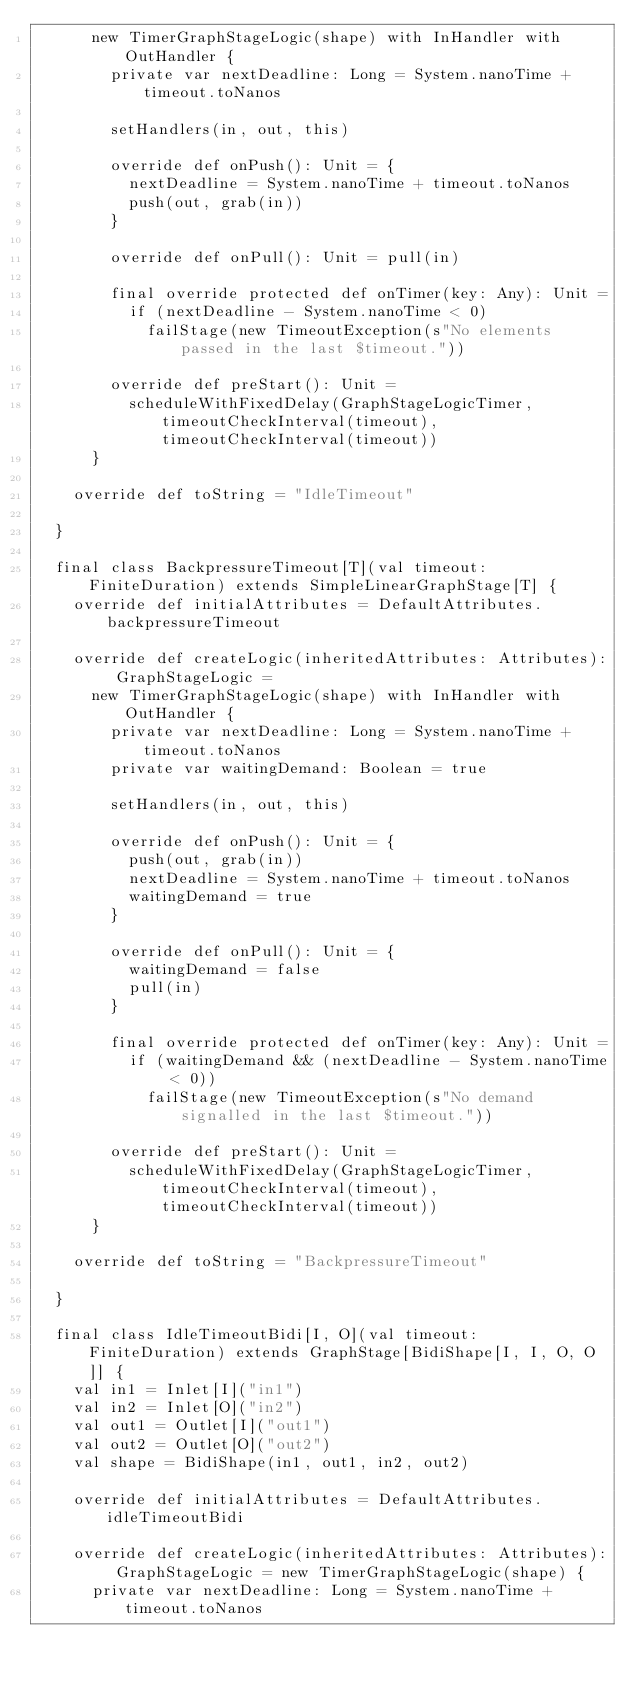<code> <loc_0><loc_0><loc_500><loc_500><_Scala_>      new TimerGraphStageLogic(shape) with InHandler with OutHandler {
        private var nextDeadline: Long = System.nanoTime + timeout.toNanos

        setHandlers(in, out, this)

        override def onPush(): Unit = {
          nextDeadline = System.nanoTime + timeout.toNanos
          push(out, grab(in))
        }

        override def onPull(): Unit = pull(in)

        final override protected def onTimer(key: Any): Unit =
          if (nextDeadline - System.nanoTime < 0)
            failStage(new TimeoutException(s"No elements passed in the last $timeout."))

        override def preStart(): Unit =
          scheduleWithFixedDelay(GraphStageLogicTimer, timeoutCheckInterval(timeout), timeoutCheckInterval(timeout))
      }

    override def toString = "IdleTimeout"

  }

  final class BackpressureTimeout[T](val timeout: FiniteDuration) extends SimpleLinearGraphStage[T] {
    override def initialAttributes = DefaultAttributes.backpressureTimeout

    override def createLogic(inheritedAttributes: Attributes): GraphStageLogic =
      new TimerGraphStageLogic(shape) with InHandler with OutHandler {
        private var nextDeadline: Long = System.nanoTime + timeout.toNanos
        private var waitingDemand: Boolean = true

        setHandlers(in, out, this)

        override def onPush(): Unit = {
          push(out, grab(in))
          nextDeadline = System.nanoTime + timeout.toNanos
          waitingDemand = true
        }

        override def onPull(): Unit = {
          waitingDemand = false
          pull(in)
        }

        final override protected def onTimer(key: Any): Unit =
          if (waitingDemand && (nextDeadline - System.nanoTime < 0))
            failStage(new TimeoutException(s"No demand signalled in the last $timeout."))

        override def preStart(): Unit =
          scheduleWithFixedDelay(GraphStageLogicTimer, timeoutCheckInterval(timeout), timeoutCheckInterval(timeout))
      }

    override def toString = "BackpressureTimeout"

  }

  final class IdleTimeoutBidi[I, O](val timeout: FiniteDuration) extends GraphStage[BidiShape[I, I, O, O]] {
    val in1 = Inlet[I]("in1")
    val in2 = Inlet[O]("in2")
    val out1 = Outlet[I]("out1")
    val out2 = Outlet[O]("out2")
    val shape = BidiShape(in1, out1, in2, out2)

    override def initialAttributes = DefaultAttributes.idleTimeoutBidi

    override def createLogic(inheritedAttributes: Attributes): GraphStageLogic = new TimerGraphStageLogic(shape) {
      private var nextDeadline: Long = System.nanoTime + timeout.toNanos
</code> 